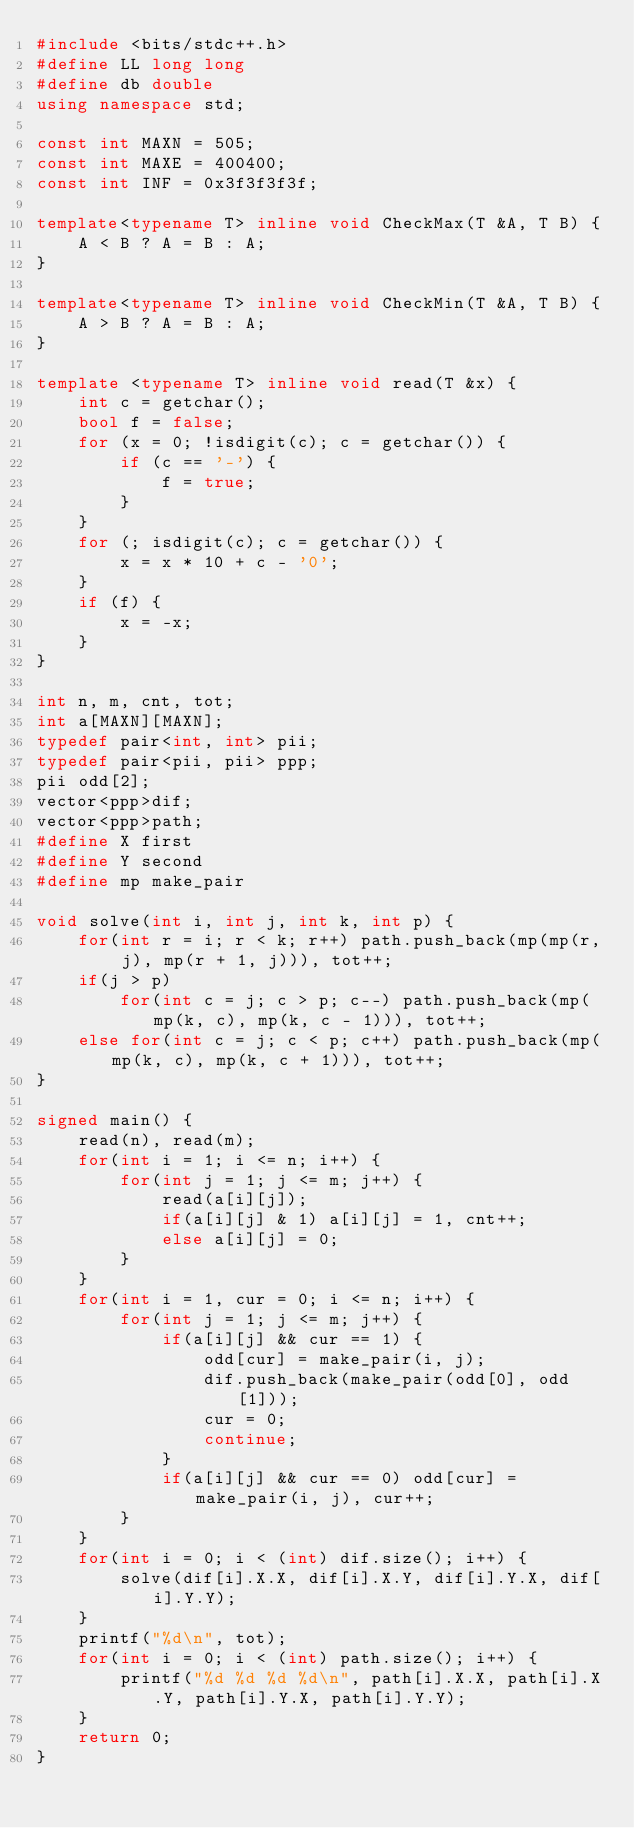<code> <loc_0><loc_0><loc_500><loc_500><_C++_>#include <bits/stdc++.h>
#define LL long long
#define db double
using namespace std;
 
const int MAXN = 505;
const int MAXE = 400400;
const int INF = 0x3f3f3f3f;
 
template<typename T> inline void CheckMax(T &A, T B) {
	A < B ? A = B : A;
}
 
template<typename T> inline void CheckMin(T &A, T B) {
	A > B ? A = B : A;
}
 
template <typename T> inline void read(T &x) {
    int c = getchar();
    bool f = false;
    for (x = 0; !isdigit(c); c = getchar()) {
        if (c == '-') {
            f = true;
        }
    }
    for (; isdigit(c); c = getchar()) {
        x = x * 10 + c - '0';
    }
    if (f) {
        x = -x;
    }
}

int n, m, cnt, tot;
int a[MAXN][MAXN];
typedef pair<int, int> pii;
typedef pair<pii, pii> ppp;
pii odd[2];
vector<ppp>dif;
vector<ppp>path;
#define X first
#define Y second
#define mp make_pair

void solve(int i, int j, int k, int p) {
	for(int r = i; r < k; r++) path.push_back(mp(mp(r, j), mp(r + 1, j))), tot++;
	if(j > p)
		for(int c = j; c > p; c--) path.push_back(mp(mp(k, c), mp(k, c - 1))), tot++;
	else for(int c = j; c < p; c++) path.push_back(mp(mp(k, c), mp(k, c + 1))), tot++;
}

signed main() {
	read(n), read(m);
	for(int i = 1; i <= n; i++) {
		for(int j = 1; j <= m; j++) {
			read(a[i][j]);
			if(a[i][j] & 1) a[i][j] = 1, cnt++;
			else a[i][j] = 0;
		}
	}
	for(int i = 1, cur = 0; i <= n; i++) {
		for(int j = 1; j <= m; j++) {
			if(a[i][j] && cur == 1) {
				odd[cur] = make_pair(i, j);
				dif.push_back(make_pair(odd[0], odd[1]));
				cur = 0;
				continue;
			}
			if(a[i][j] && cur == 0) odd[cur] = make_pair(i, j), cur++;
		}
	}
	for(int i = 0; i < (int) dif.size(); i++) {
		solve(dif[i].X.X, dif[i].X.Y, dif[i].Y.X, dif[i].Y.Y);
	}
	printf("%d\n", tot);
	for(int i = 0; i < (int) path.size(); i++) {
		printf("%d %d %d %d\n", path[i].X.X, path[i].X.Y, path[i].Y.X, path[i].Y.Y);
	}
	return 0;
}</code> 